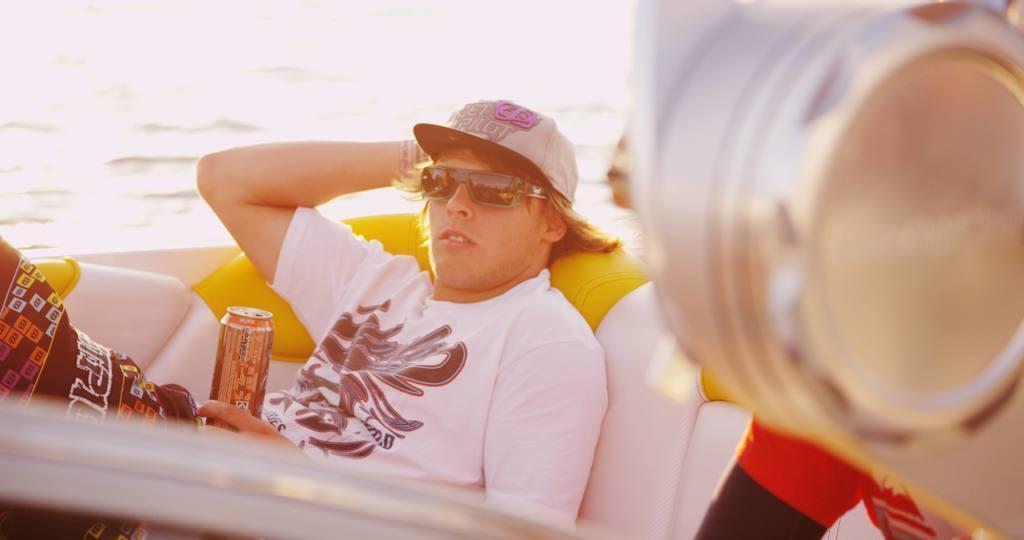In one or two sentences, can you explain what this image depicts? In the center of the image there is a person sitting on the couch wearing sunglasses and cap. There is a coke tin in his hand. To the right side of the image there is a object. In the background of the image there is water. 